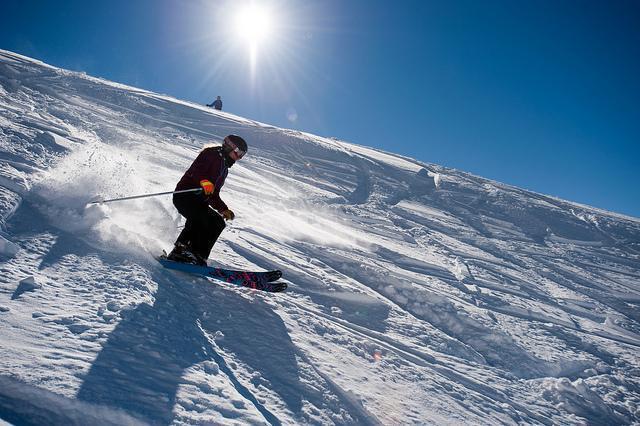Which EU country might be associated with the colors of the skier's gloves?
From the following four choices, select the correct answer to address the question.
Options: France, croatia, poland, netherlands. Netherlands. 